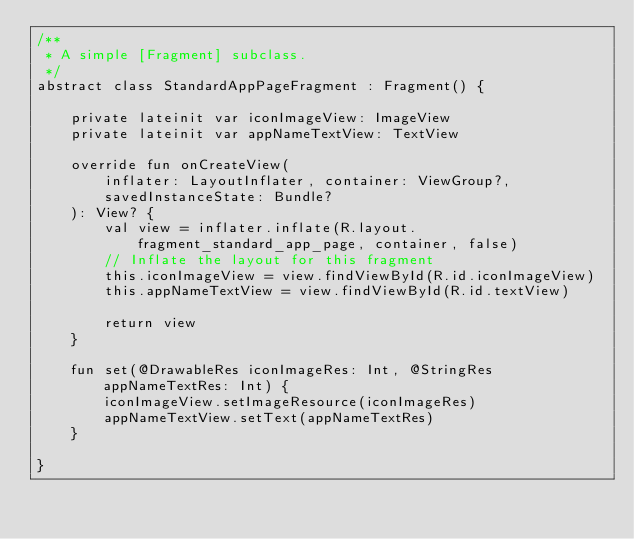<code> <loc_0><loc_0><loc_500><loc_500><_Kotlin_>/**
 * A simple [Fragment] subclass.
 */
abstract class StandardAppPageFragment : Fragment() {

    private lateinit var iconImageView: ImageView
    private lateinit var appNameTextView: TextView

    override fun onCreateView(
        inflater: LayoutInflater, container: ViewGroup?,
        savedInstanceState: Bundle?
    ): View? {
        val view = inflater.inflate(R.layout.fragment_standard_app_page, container, false)
        // Inflate the layout for this fragment
        this.iconImageView = view.findViewById(R.id.iconImageView)
        this.appNameTextView = view.findViewById(R.id.textView)

        return view
    }

    fun set(@DrawableRes iconImageRes: Int, @StringRes appNameTextRes: Int) {
        iconImageView.setImageResource(iconImageRes)
        appNameTextView.setText(appNameTextRes)
    }

}
</code> 